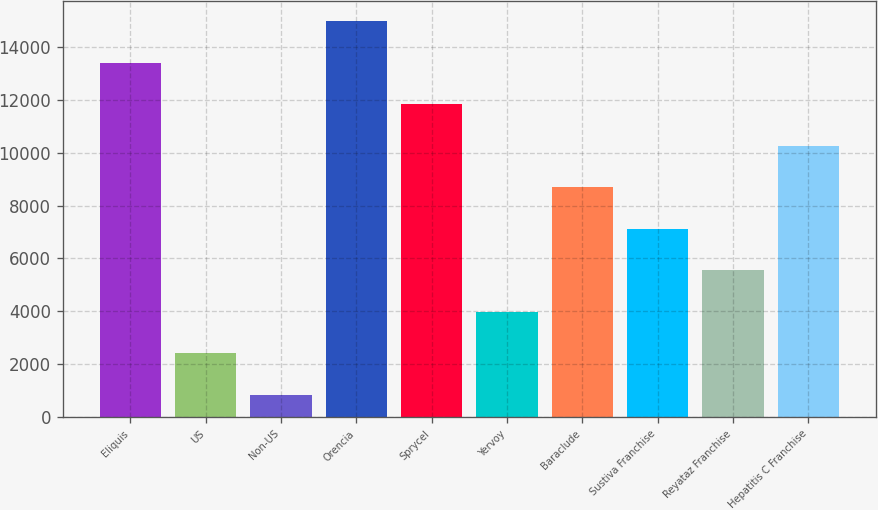Convert chart. <chart><loc_0><loc_0><loc_500><loc_500><bar_chart><fcel>Eliquis<fcel>US<fcel>Non-US<fcel>Orencia<fcel>Sprycel<fcel>Yervoy<fcel>Baraclude<fcel>Sustiva Franchise<fcel>Reyataz Franchise<fcel>Hepatitis C Franchise<nl><fcel>13415.4<fcel>2409.3<fcel>837<fcel>14987.7<fcel>11843.1<fcel>3981.6<fcel>8698.5<fcel>7126.2<fcel>5553.9<fcel>10270.8<nl></chart> 